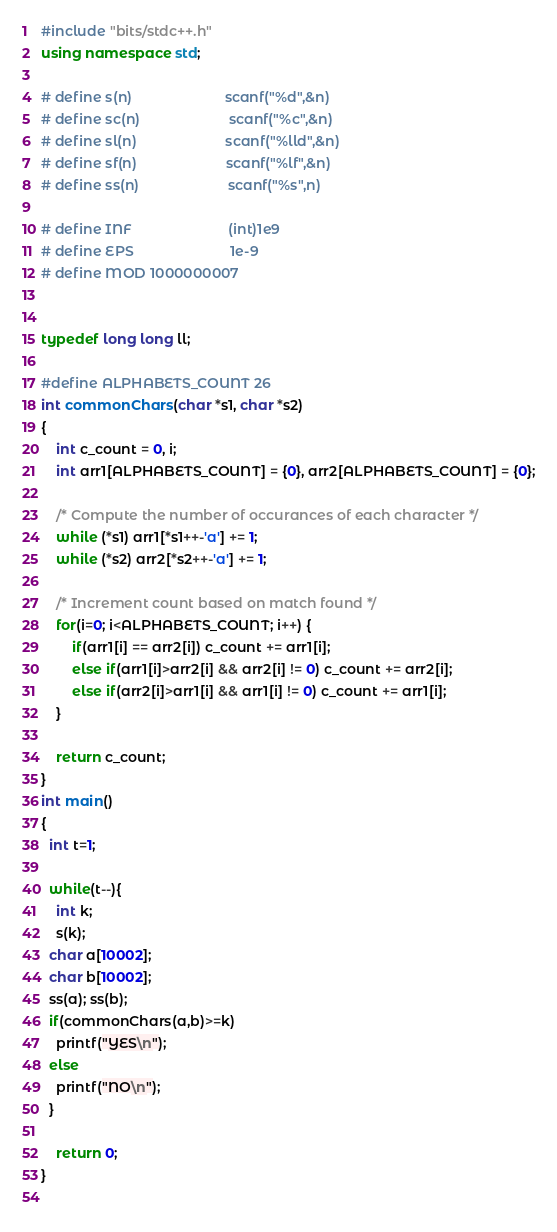Convert code to text. <code><loc_0><loc_0><loc_500><loc_500><_C++_>#include "bits/stdc++.h"
using namespace std;

# define s(n)                        scanf("%d",&n)
# define sc(n)                       scanf("%c",&n)
# define sl(n)                       scanf("%lld",&n)
# define sf(n)                       scanf("%lf",&n)
# define ss(n)                       scanf("%s",n)

# define INF                         (int)1e9
# define EPS                         1e-9
# define MOD 1000000007


typedef long long ll;

#define ALPHABETS_COUNT 26 
int commonChars(char *s1, char *s2)
{
    int c_count = 0, i; 
    int arr1[ALPHABETS_COUNT] = {0}, arr2[ALPHABETS_COUNT] = {0};

    /* Compute the number of occurances of each character */
    while (*s1) arr1[*s1++-'a'] += 1;
    while (*s2) arr2[*s2++-'a'] += 1;       

    /* Increment count based on match found */
    for(i=0; i<ALPHABETS_COUNT; i++) {
        if(arr1[i] == arr2[i]) c_count += arr1[i];
        else if(arr1[i]>arr2[i] && arr2[i] != 0) c_count += arr2[i];
        else if(arr2[i]>arr1[i] && arr1[i] != 0) c_count += arr1[i];
    }

    return c_count;
}
int main()
{
  int t=1;
 
  while(t--){
  	int k;
  	s(k);
  char a[10002];
  char b[10002];  
  ss(a); ss(b);
  if(commonChars(a,b)>=k)
  	printf("YES\n");
  else
  	printf("NO\n");
  }
	
	return 0;
}
	</code> 